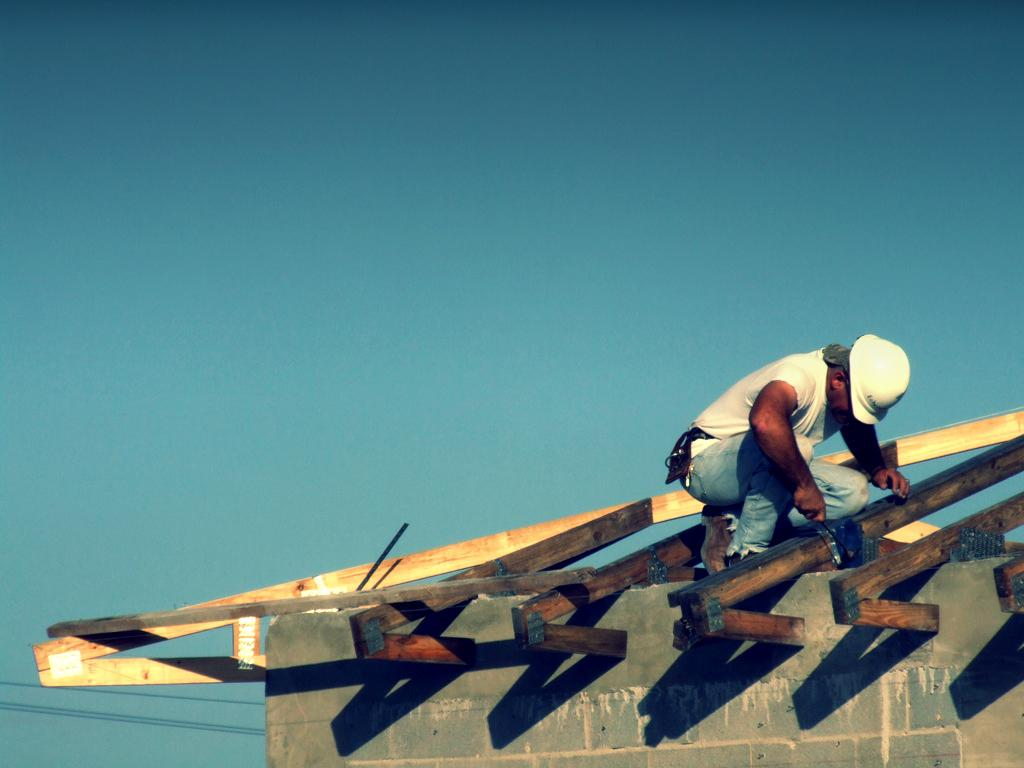What is the man in the image doing? The man is sitting on the roof of the building. What can be seen on the roof of the building besides the man? There are wooden poles on the roof of the building. What is the condition of the sky in the image? The sky is clear in the image. Where is the clam located in the image? There is no clam present in the image. What type of rail is supporting the man on the roof? The image does not show any rails supporting the man on the roof. 